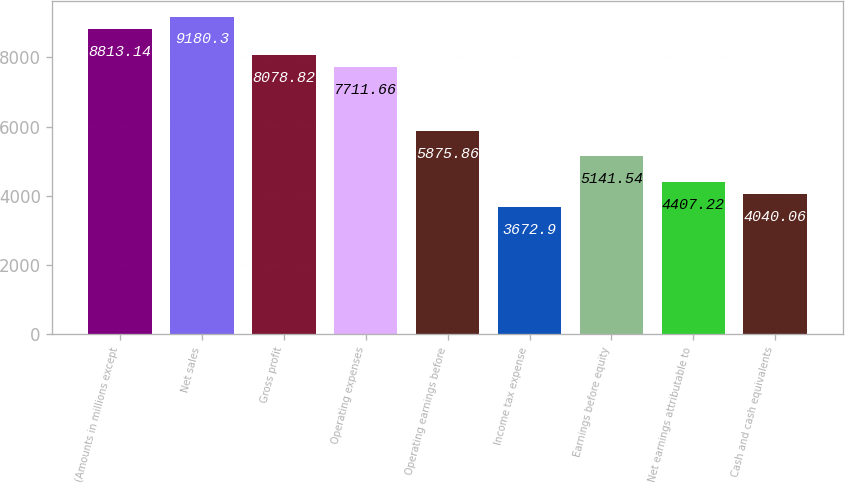<chart> <loc_0><loc_0><loc_500><loc_500><bar_chart><fcel>(Amounts in millions except<fcel>Net sales<fcel>Gross profit<fcel>Operating expenses<fcel>Operating earnings before<fcel>Income tax expense<fcel>Earnings before equity<fcel>Net earnings attributable to<fcel>Cash and cash equivalents<nl><fcel>8813.14<fcel>9180.3<fcel>8078.82<fcel>7711.66<fcel>5875.86<fcel>3672.9<fcel>5141.54<fcel>4407.22<fcel>4040.06<nl></chart> 